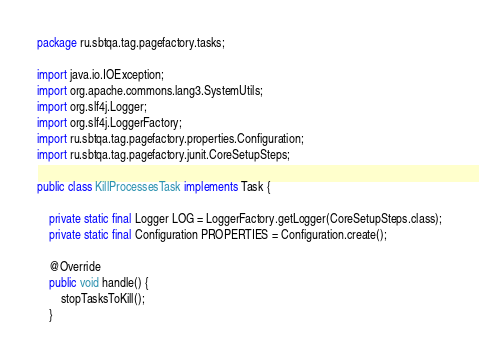<code> <loc_0><loc_0><loc_500><loc_500><_Java_>package ru.sbtqa.tag.pagefactory.tasks;

import java.io.IOException;
import org.apache.commons.lang3.SystemUtils;
import org.slf4j.Logger;
import org.slf4j.LoggerFactory;
import ru.sbtqa.tag.pagefactory.properties.Configuration;
import ru.sbtqa.tag.pagefactory.junit.CoreSetupSteps;

public class KillProcessesTask implements Task {

    private static final Logger LOG = LoggerFactory.getLogger(CoreSetupSteps.class);
    private static final Configuration PROPERTIES = Configuration.create();

    @Override
    public void handle() {
        stopTasksToKill();
    }
</code> 